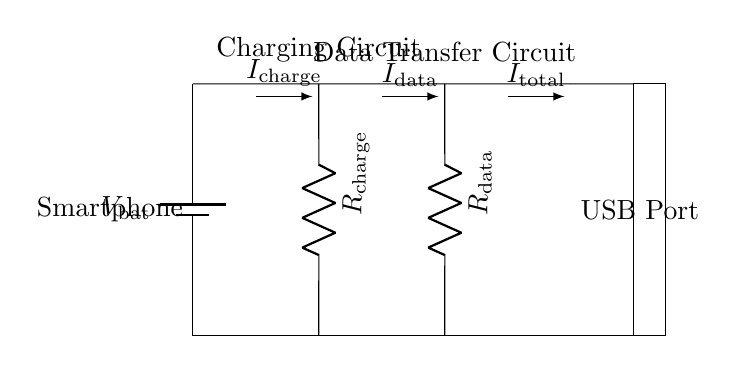What type of circuit is depicted? The circuit is a parallel circuit, as it shows multiple components connected alongside each other, allowing for different paths for current to flow.
Answer: Parallel circuit What are the two main functions represented in the circuit? The circuit features two main functions: charging and data transfer, indicated by the respective resistors labeled for each function.
Answer: Charging and data transfer What is the total current flowing in this circuit? The total current, denoted as I_total, combines the currents for both the charging (I_charge) and data transfer (I_data) paths, but the exact value is not specified in the diagram.
Answer: I_total What is the role of the USB port in this circuit? The USB port serves as the connection point for the smartphone to connect for both charging and data transfer purposes, facilitating the interactions with external devices.
Answer: Connection point What happens if one of the resistors in a parallel circuit fails? If one resistor fails in a parallel circuit, the other paths still allow current to flow, meaning the remaining functions (charging or data transfer) can continue to operate independently.
Answer: Functionality continues What are the resistance labels in the circuit diagram? The resistances in the circuit are labeled as R_charge and R_data, indicating the specific resistance values for each function's pathway.
Answer: R_charge and R_data 